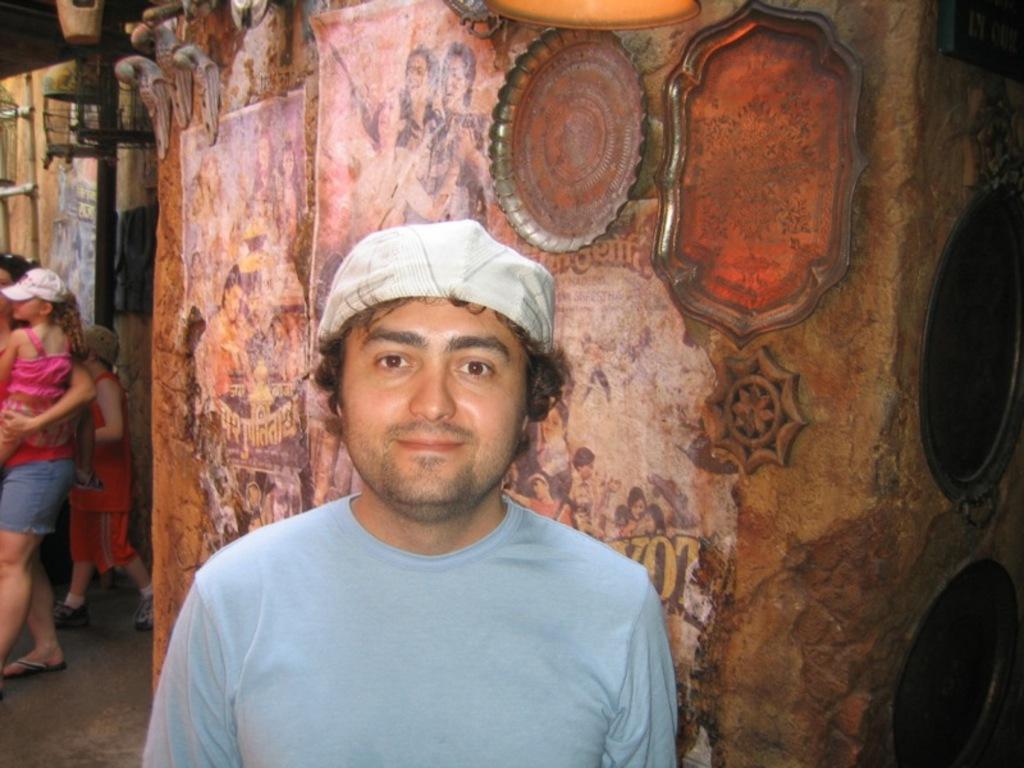How would you summarize this image in a sentence or two? In this image we can see a man who is wearing grey color t-shirt and cap. Behind him wall is there. On wall frames and things are attached. Left side of the image one lady is there, she is carrying a girl in her hand and one boy is present. Behind the pole is present. 